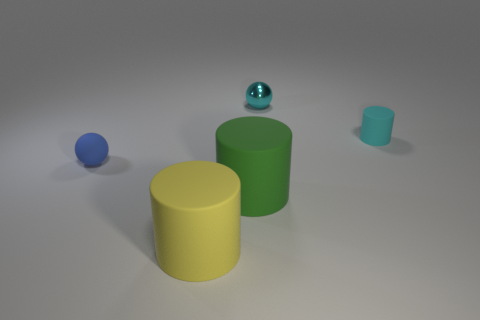Do the rubber thing to the right of the green object and the shiny sphere have the same color?
Offer a very short reply. Yes. What number of other objects are there of the same size as the cyan matte object?
Make the answer very short. 2. Is there a small cyan metal cylinder?
Make the answer very short. No. How big is the cylinder that is on the right side of the small sphere that is behind the blue rubber sphere?
Ensure brevity in your answer.  Small. There is a sphere that is to the right of the yellow rubber object; is it the same color as the tiny rubber thing that is on the right side of the metallic ball?
Your answer should be compact. Yes. What color is the rubber object that is to the left of the green object and in front of the tiny blue sphere?
Keep it short and to the point. Yellow. What number of other objects are there of the same shape as the cyan matte thing?
Your response must be concise. 2. What color is the metal ball that is the same size as the blue matte ball?
Give a very brief answer. Cyan. What color is the small object to the left of the large green cylinder?
Keep it short and to the point. Blue. There is a tiny ball in front of the tiny cyan ball; are there any rubber objects that are in front of it?
Make the answer very short. Yes. 